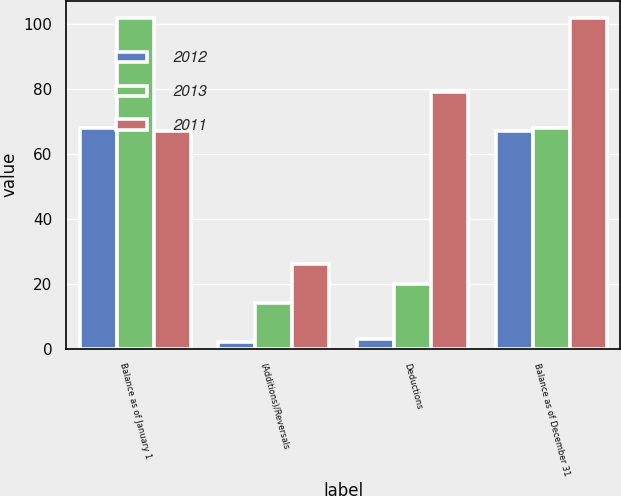<chart> <loc_0><loc_0><loc_500><loc_500><stacked_bar_chart><ecel><fcel>Balance as of January 1<fcel>(Additions)/Reversals<fcel>Deductions<fcel>Balance as of December 31<nl><fcel>2012<fcel>68<fcel>2<fcel>3<fcel>67<nl><fcel>2013<fcel>102<fcel>14<fcel>20<fcel>68<nl><fcel>2011<fcel>67<fcel>26<fcel>79<fcel>102<nl></chart> 